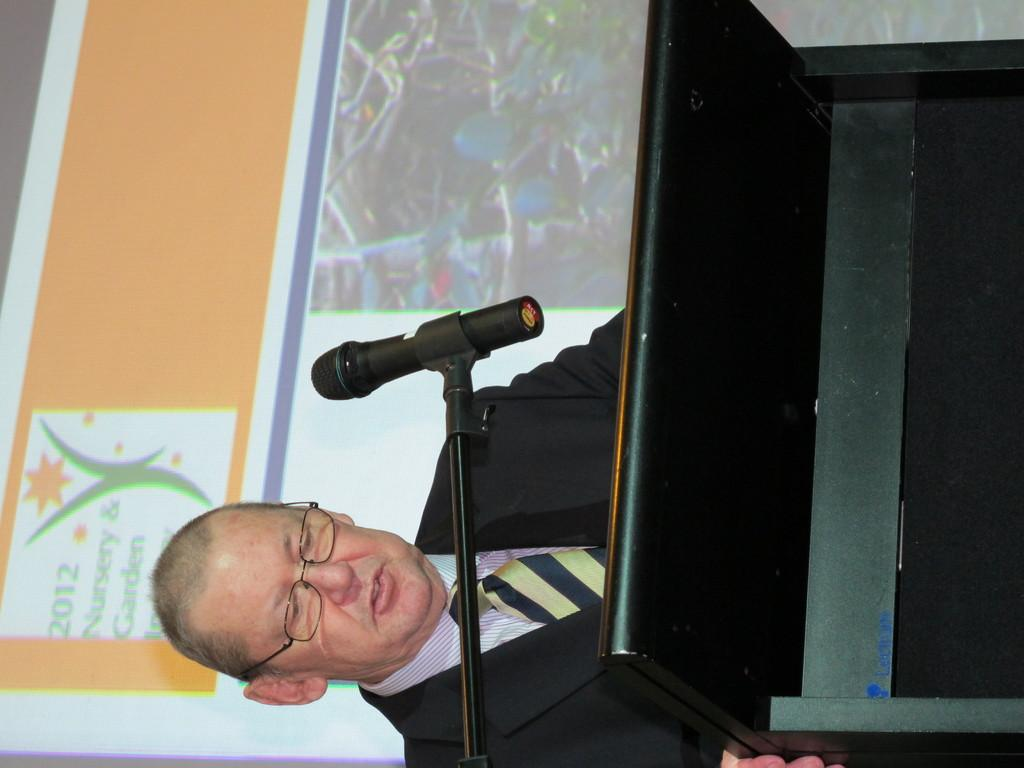What is the person in the image doing near the podium? The person is standing near a podium. What device is present for amplifying the person's voice? There is a microphone in the image. How is the microphone positioned in the image? There is a microphone stand in the image. What can be seen on the screen in the image? There is a screen in the image. What color of paint is being used to decorate the kettle in the image? There is no kettle present in the image, so it is not possible to determine the color of paint being used to decorate it. 